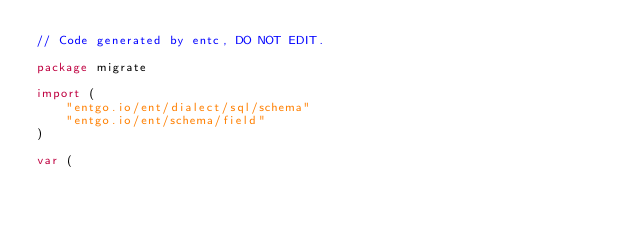<code> <loc_0><loc_0><loc_500><loc_500><_Go_>// Code generated by entc, DO NOT EDIT.

package migrate

import (
	"entgo.io/ent/dialect/sql/schema"
	"entgo.io/ent/schema/field"
)

var (</code> 